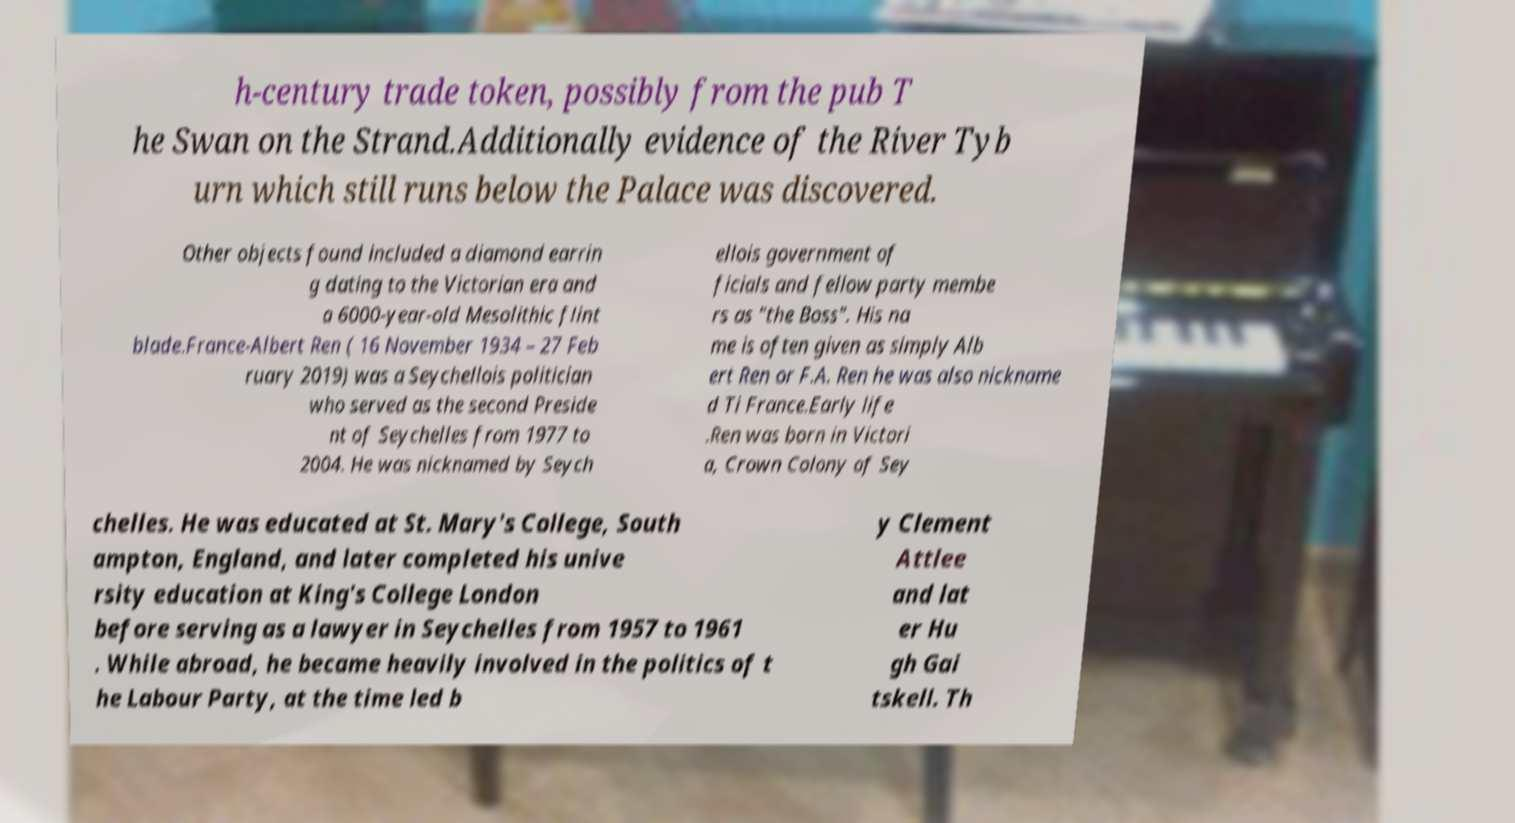What messages or text are displayed in this image? I need them in a readable, typed format. h-century trade token, possibly from the pub T he Swan on the Strand.Additionally evidence of the River Tyb urn which still runs below the Palace was discovered. Other objects found included a diamond earrin g dating to the Victorian era and a 6000-year-old Mesolithic flint blade.France-Albert Ren ( 16 November 1934 – 27 Feb ruary 2019) was a Seychellois politician who served as the second Preside nt of Seychelles from 1977 to 2004. He was nicknamed by Seych ellois government of ficials and fellow party membe rs as "the Boss". His na me is often given as simply Alb ert Ren or F.A. Ren he was also nickname d Ti France.Early life .Ren was born in Victori a, Crown Colony of Sey chelles. He was educated at St. Mary's College, South ampton, England, and later completed his unive rsity education at King's College London before serving as a lawyer in Seychelles from 1957 to 1961 . While abroad, he became heavily involved in the politics of t he Labour Party, at the time led b y Clement Attlee and lat er Hu gh Gai tskell. Th 